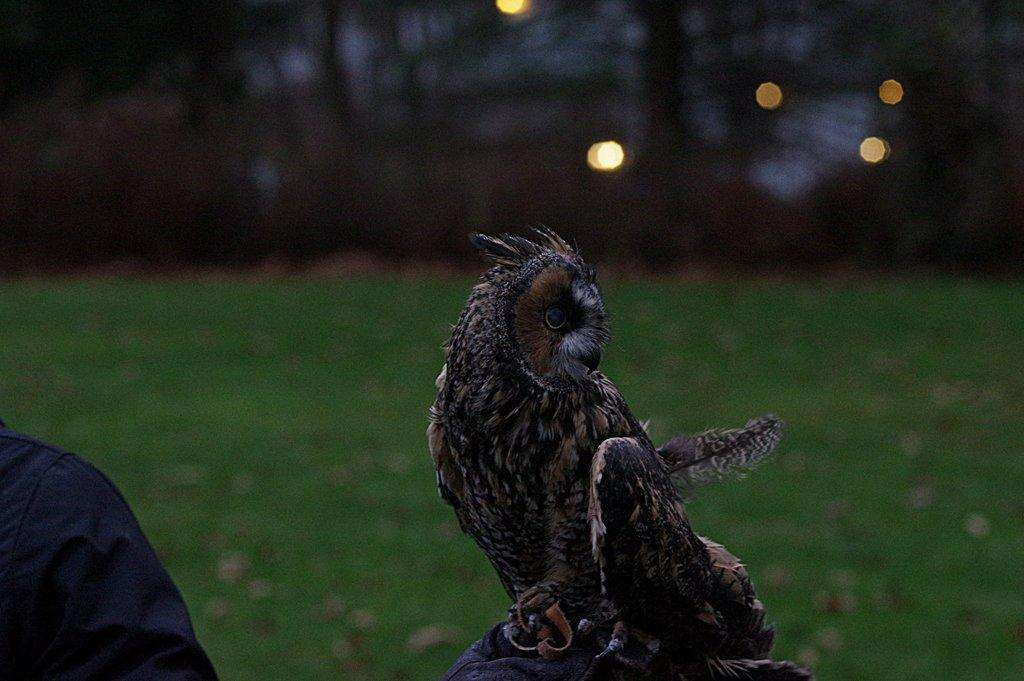What type of animal is in the image? There is a bird in the image. Can you describe the bird's coloring? The bird has brown and black colors. What can be seen in the background of the image? The background of the image includes green grass. What type of control does the bird have over the tiger in the image? There is no tiger present in the image, so the bird does not have any control over a tiger. 